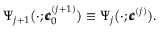<formula> <loc_0><loc_0><loc_500><loc_500>\Psi _ { j + 1 } \left ( \cdot ; \pm b { c } _ { 0 } ^ { ( j + 1 ) } \right ) \equiv \Psi _ { j } \left ( \cdot ; \pm b { c } ^ { ( j ) } \right ) .</formula> 